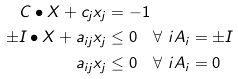<formula> <loc_0><loc_0><loc_500><loc_500>C \bullet X + c _ { j } x _ { j } & = - 1 \\ \pm I \bullet X + a _ { i j } x _ { j } & \leq 0 \quad \forall \ i A _ { i } = \pm I \\ a _ { i j } x _ { j } & \leq 0 \quad \forall \ i A _ { i } = 0</formula> 